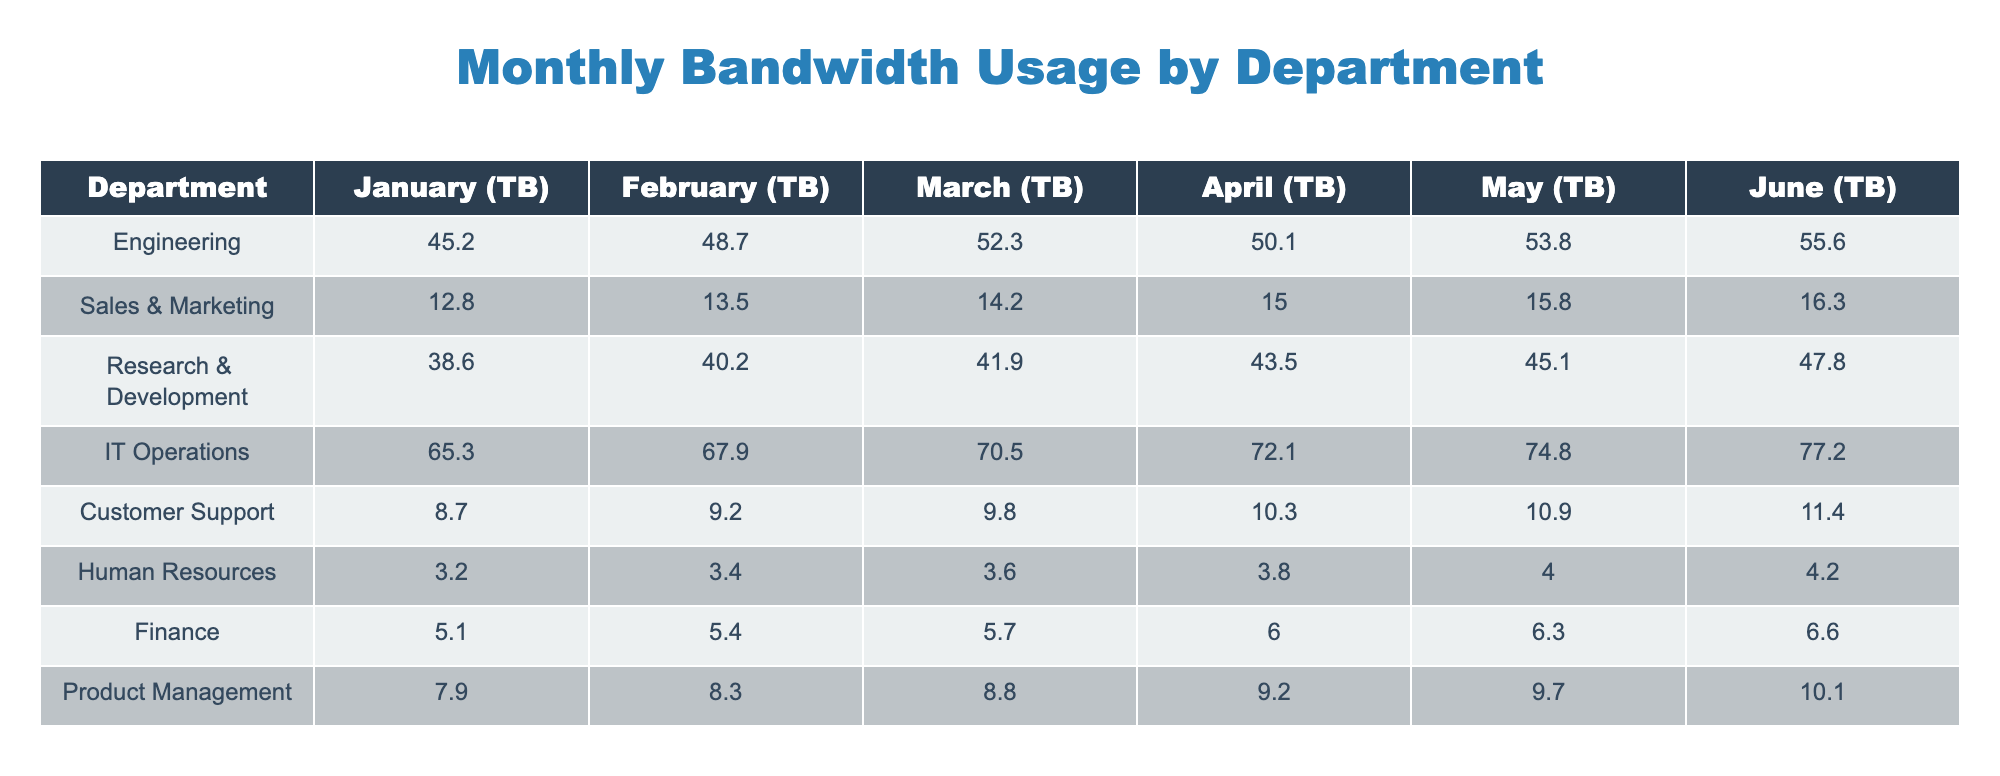What was the bandwidth usage by IT Operations in March? According to the table, the value corresponding to IT Operations for March is listed under the "March (TB)" column, which shows a value of 70.5 TB.
Answer: 70.5 TB Which department had the highest bandwidth usage in April? By examining the "April (TB)" column, we see that IT Operations has the highest value at 72.1 TB compared to other departments.
Answer: IT Operations What was the average monthly bandwidth usage for the Sales & Marketing department? To find the average, we sum the monthly values for Sales & Marketing: 12.8 + 13.5 + 14.2 + 15.0 + 15.8 + 16.3 = 87.6 TB. There are 6 months, so the average is 87.6 / 6 = 14.6 TB.
Answer: 14.6 TB Did Human Resources use more than 5 TB of bandwidth in any month? Looking at the values in the "Human Resources" row, all monthly values are below 5 TB: 3.2, 3.4, 3.6, 3.8, 4.0, and 4.2 TB, confirming that they did not exceed 5 TB in any month.
Answer: No What was the total bandwidth usage for Engineering from January to June? We will add up the monthly values for Engineering: 45.2 + 48.7 + 52.3 + 50.1 + 53.8 + 55.6 = 305.7 TB for the total over these six months.
Answer: 305.7 TB Which department saw the largest increase in bandwidth usage from January to June? By comparing the data, we calculate the increase for each department: for IT Operations, it went from 65.3 TB to 77.2 TB (11.9 TB increase). Engineering increased from 45.2 TB to 55.6 TB (10.4 TB), and so on. IT Operations has the largest increase at 11.9 TB.
Answer: IT Operations What is the median monthly bandwidth usage for the Research & Development department over the six months? To find the median, we first list the monthly values for Research & Development: 38.6, 40.2, 41.9, 43.5, 45.1, 47.8. Sorting them in order doesn't change them since they are already in increasing order. The median (the average of the 3rd and 4th value) is (41.9 + 43.5) / 2 = 42.7 TB.
Answer: 42.7 TB How much more bandwidth did IT Operations use compared to Finance in May? The value for IT Operations in May is 74.8 TB, while for Finance it is 6.3 TB. The difference is 74.8 - 6.3 = 68.5 TB.
Answer: 68.5 TB 